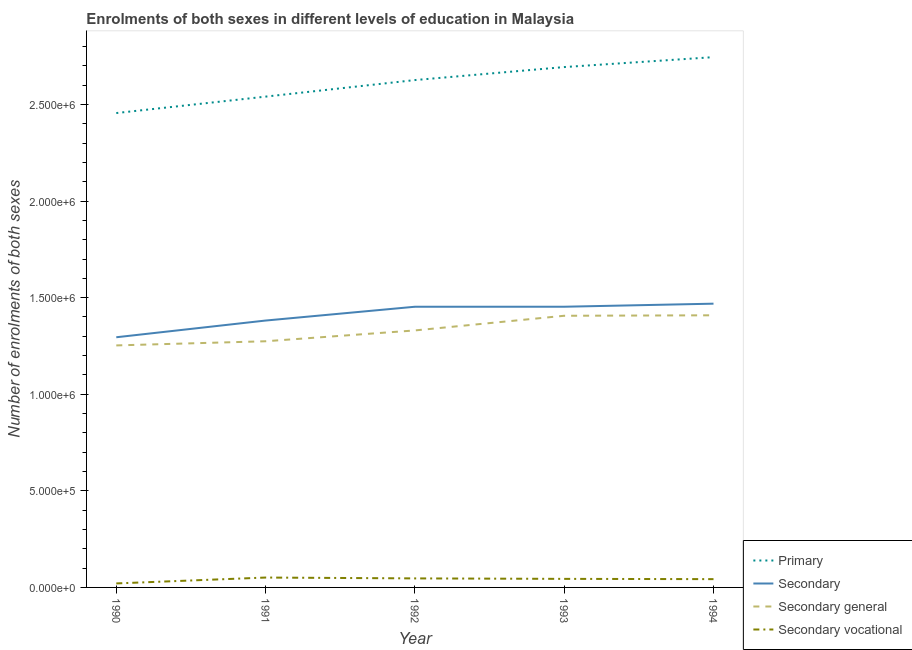How many different coloured lines are there?
Ensure brevity in your answer.  4. Does the line corresponding to number of enrolments in primary education intersect with the line corresponding to number of enrolments in secondary education?
Ensure brevity in your answer.  No. What is the number of enrolments in primary education in 1991?
Make the answer very short. 2.54e+06. Across all years, what is the maximum number of enrolments in secondary vocational education?
Provide a short and direct response. 5.12e+04. Across all years, what is the minimum number of enrolments in secondary general education?
Offer a terse response. 1.25e+06. What is the total number of enrolments in secondary education in the graph?
Your answer should be compact. 7.05e+06. What is the difference between the number of enrolments in secondary education in 1991 and that in 1992?
Make the answer very short. -7.14e+04. What is the difference between the number of enrolments in secondary general education in 1992 and the number of enrolments in secondary vocational education in 1990?
Ensure brevity in your answer.  1.31e+06. What is the average number of enrolments in secondary general education per year?
Your answer should be very brief. 1.33e+06. In the year 1994, what is the difference between the number of enrolments in secondary education and number of enrolments in secondary vocational education?
Your answer should be compact. 1.43e+06. In how many years, is the number of enrolments in secondary education greater than 200000?
Ensure brevity in your answer.  5. What is the ratio of the number of enrolments in secondary vocational education in 1991 to that in 1994?
Offer a very short reply. 1.19. Is the difference between the number of enrolments in secondary education in 1992 and 1993 greater than the difference between the number of enrolments in primary education in 1992 and 1993?
Provide a succinct answer. Yes. What is the difference between the highest and the second highest number of enrolments in secondary education?
Your answer should be compact. 1.59e+04. What is the difference between the highest and the lowest number of enrolments in primary education?
Keep it short and to the point. 2.89e+05. In how many years, is the number of enrolments in secondary vocational education greater than the average number of enrolments in secondary vocational education taken over all years?
Keep it short and to the point. 4. Is the sum of the number of enrolments in primary education in 1990 and 1992 greater than the maximum number of enrolments in secondary general education across all years?
Give a very brief answer. Yes. Is it the case that in every year, the sum of the number of enrolments in primary education and number of enrolments in secondary education is greater than the number of enrolments in secondary general education?
Make the answer very short. Yes. Is the number of enrolments in primary education strictly less than the number of enrolments in secondary education over the years?
Offer a terse response. No. How many lines are there?
Keep it short and to the point. 4. How many years are there in the graph?
Make the answer very short. 5. Are the values on the major ticks of Y-axis written in scientific E-notation?
Provide a short and direct response. Yes. Does the graph contain any zero values?
Your answer should be compact. No. Does the graph contain grids?
Your answer should be very brief. No. Where does the legend appear in the graph?
Ensure brevity in your answer.  Bottom right. How are the legend labels stacked?
Give a very brief answer. Vertical. What is the title of the graph?
Make the answer very short. Enrolments of both sexes in different levels of education in Malaysia. What is the label or title of the Y-axis?
Offer a terse response. Number of enrolments of both sexes. What is the Number of enrolments of both sexes of Primary in 1990?
Provide a short and direct response. 2.46e+06. What is the Number of enrolments of both sexes in Secondary in 1990?
Give a very brief answer. 1.29e+06. What is the Number of enrolments of both sexes in Secondary general in 1990?
Your answer should be very brief. 1.25e+06. What is the Number of enrolments of both sexes in Secondary vocational in 1990?
Your answer should be very brief. 2.07e+04. What is the Number of enrolments of both sexes of Primary in 1991?
Your response must be concise. 2.54e+06. What is the Number of enrolments of both sexes of Secondary in 1991?
Your answer should be compact. 1.38e+06. What is the Number of enrolments of both sexes in Secondary general in 1991?
Offer a terse response. 1.27e+06. What is the Number of enrolments of both sexes in Secondary vocational in 1991?
Ensure brevity in your answer.  5.12e+04. What is the Number of enrolments of both sexes in Primary in 1992?
Give a very brief answer. 2.63e+06. What is the Number of enrolments of both sexes in Secondary in 1992?
Make the answer very short. 1.45e+06. What is the Number of enrolments of both sexes in Secondary general in 1992?
Provide a short and direct response. 1.33e+06. What is the Number of enrolments of both sexes of Secondary vocational in 1992?
Offer a terse response. 4.67e+04. What is the Number of enrolments of both sexes of Primary in 1993?
Your answer should be compact. 2.69e+06. What is the Number of enrolments of both sexes in Secondary in 1993?
Offer a terse response. 1.45e+06. What is the Number of enrolments of both sexes in Secondary general in 1993?
Your response must be concise. 1.41e+06. What is the Number of enrolments of both sexes in Secondary vocational in 1993?
Provide a short and direct response. 4.43e+04. What is the Number of enrolments of both sexes of Primary in 1994?
Your answer should be compact. 2.74e+06. What is the Number of enrolments of both sexes of Secondary in 1994?
Offer a very short reply. 1.47e+06. What is the Number of enrolments of both sexes of Secondary general in 1994?
Ensure brevity in your answer.  1.41e+06. What is the Number of enrolments of both sexes in Secondary vocational in 1994?
Your response must be concise. 4.29e+04. Across all years, what is the maximum Number of enrolments of both sexes of Primary?
Provide a succinct answer. 2.74e+06. Across all years, what is the maximum Number of enrolments of both sexes in Secondary?
Keep it short and to the point. 1.47e+06. Across all years, what is the maximum Number of enrolments of both sexes of Secondary general?
Offer a terse response. 1.41e+06. Across all years, what is the maximum Number of enrolments of both sexes of Secondary vocational?
Your answer should be very brief. 5.12e+04. Across all years, what is the minimum Number of enrolments of both sexes of Primary?
Keep it short and to the point. 2.46e+06. Across all years, what is the minimum Number of enrolments of both sexes in Secondary?
Your answer should be compact. 1.29e+06. Across all years, what is the minimum Number of enrolments of both sexes of Secondary general?
Provide a succinct answer. 1.25e+06. Across all years, what is the minimum Number of enrolments of both sexes in Secondary vocational?
Offer a very short reply. 2.07e+04. What is the total Number of enrolments of both sexes in Primary in the graph?
Keep it short and to the point. 1.31e+07. What is the total Number of enrolments of both sexes of Secondary in the graph?
Ensure brevity in your answer.  7.05e+06. What is the total Number of enrolments of both sexes in Secondary general in the graph?
Provide a succinct answer. 6.67e+06. What is the total Number of enrolments of both sexes of Secondary vocational in the graph?
Make the answer very short. 2.06e+05. What is the difference between the Number of enrolments of both sexes of Primary in 1990 and that in 1991?
Keep it short and to the point. -8.51e+04. What is the difference between the Number of enrolments of both sexes of Secondary in 1990 and that in 1991?
Ensure brevity in your answer.  -8.65e+04. What is the difference between the Number of enrolments of both sexes of Secondary general in 1990 and that in 1991?
Give a very brief answer. -2.15e+04. What is the difference between the Number of enrolments of both sexes of Secondary vocational in 1990 and that in 1991?
Your answer should be compact. -3.04e+04. What is the difference between the Number of enrolments of both sexes of Primary in 1990 and that in 1992?
Make the answer very short. -1.71e+05. What is the difference between the Number of enrolments of both sexes in Secondary in 1990 and that in 1992?
Your answer should be very brief. -1.58e+05. What is the difference between the Number of enrolments of both sexes in Secondary general in 1990 and that in 1992?
Give a very brief answer. -7.76e+04. What is the difference between the Number of enrolments of both sexes of Secondary vocational in 1990 and that in 1992?
Keep it short and to the point. -2.60e+04. What is the difference between the Number of enrolments of both sexes in Primary in 1990 and that in 1993?
Keep it short and to the point. -2.38e+05. What is the difference between the Number of enrolments of both sexes of Secondary in 1990 and that in 1993?
Your answer should be compact. -1.58e+05. What is the difference between the Number of enrolments of both sexes of Secondary general in 1990 and that in 1993?
Give a very brief answer. -1.53e+05. What is the difference between the Number of enrolments of both sexes of Secondary vocational in 1990 and that in 1993?
Ensure brevity in your answer.  -2.36e+04. What is the difference between the Number of enrolments of both sexes of Primary in 1990 and that in 1994?
Give a very brief answer. -2.89e+05. What is the difference between the Number of enrolments of both sexes in Secondary in 1990 and that in 1994?
Provide a short and direct response. -1.74e+05. What is the difference between the Number of enrolments of both sexes in Secondary general in 1990 and that in 1994?
Offer a very short reply. -1.56e+05. What is the difference between the Number of enrolments of both sexes of Secondary vocational in 1990 and that in 1994?
Your answer should be very brief. -2.22e+04. What is the difference between the Number of enrolments of both sexes in Primary in 1991 and that in 1992?
Offer a terse response. -8.57e+04. What is the difference between the Number of enrolments of both sexes in Secondary in 1991 and that in 1992?
Make the answer very short. -7.14e+04. What is the difference between the Number of enrolments of both sexes of Secondary general in 1991 and that in 1992?
Provide a succinct answer. -5.61e+04. What is the difference between the Number of enrolments of both sexes of Secondary vocational in 1991 and that in 1992?
Make the answer very short. 4465. What is the difference between the Number of enrolments of both sexes of Primary in 1991 and that in 1993?
Provide a short and direct response. -1.53e+05. What is the difference between the Number of enrolments of both sexes in Secondary in 1991 and that in 1993?
Make the answer very short. -7.15e+04. What is the difference between the Number of enrolments of both sexes of Secondary general in 1991 and that in 1993?
Make the answer very short. -1.32e+05. What is the difference between the Number of enrolments of both sexes of Secondary vocational in 1991 and that in 1993?
Provide a succinct answer. 6869. What is the difference between the Number of enrolments of both sexes of Primary in 1991 and that in 1994?
Provide a short and direct response. -2.04e+05. What is the difference between the Number of enrolments of both sexes in Secondary in 1991 and that in 1994?
Make the answer very short. -8.73e+04. What is the difference between the Number of enrolments of both sexes in Secondary general in 1991 and that in 1994?
Your response must be concise. -1.34e+05. What is the difference between the Number of enrolments of both sexes in Secondary vocational in 1991 and that in 1994?
Give a very brief answer. 8262. What is the difference between the Number of enrolments of both sexes of Primary in 1992 and that in 1993?
Provide a succinct answer. -6.73e+04. What is the difference between the Number of enrolments of both sexes of Secondary in 1992 and that in 1993?
Give a very brief answer. -42. What is the difference between the Number of enrolments of both sexes in Secondary general in 1992 and that in 1993?
Provide a short and direct response. -7.59e+04. What is the difference between the Number of enrolments of both sexes in Secondary vocational in 1992 and that in 1993?
Provide a succinct answer. 2404. What is the difference between the Number of enrolments of both sexes in Primary in 1992 and that in 1994?
Offer a terse response. -1.19e+05. What is the difference between the Number of enrolments of both sexes in Secondary in 1992 and that in 1994?
Provide a succinct answer. -1.59e+04. What is the difference between the Number of enrolments of both sexes in Secondary general in 1992 and that in 1994?
Provide a short and direct response. -7.83e+04. What is the difference between the Number of enrolments of both sexes of Secondary vocational in 1992 and that in 1994?
Keep it short and to the point. 3797. What is the difference between the Number of enrolments of both sexes in Primary in 1993 and that in 1994?
Make the answer very short. -5.14e+04. What is the difference between the Number of enrolments of both sexes in Secondary in 1993 and that in 1994?
Give a very brief answer. -1.59e+04. What is the difference between the Number of enrolments of both sexes in Secondary general in 1993 and that in 1994?
Provide a succinct answer. -2446. What is the difference between the Number of enrolments of both sexes in Secondary vocational in 1993 and that in 1994?
Provide a succinct answer. 1393. What is the difference between the Number of enrolments of both sexes in Primary in 1990 and the Number of enrolments of both sexes in Secondary in 1991?
Make the answer very short. 1.07e+06. What is the difference between the Number of enrolments of both sexes of Primary in 1990 and the Number of enrolments of both sexes of Secondary general in 1991?
Keep it short and to the point. 1.18e+06. What is the difference between the Number of enrolments of both sexes in Primary in 1990 and the Number of enrolments of both sexes in Secondary vocational in 1991?
Offer a terse response. 2.40e+06. What is the difference between the Number of enrolments of both sexes of Secondary in 1990 and the Number of enrolments of both sexes of Secondary general in 1991?
Ensure brevity in your answer.  2.07e+04. What is the difference between the Number of enrolments of both sexes in Secondary in 1990 and the Number of enrolments of both sexes in Secondary vocational in 1991?
Provide a short and direct response. 1.24e+06. What is the difference between the Number of enrolments of both sexes in Secondary general in 1990 and the Number of enrolments of both sexes in Secondary vocational in 1991?
Provide a succinct answer. 1.20e+06. What is the difference between the Number of enrolments of both sexes in Primary in 1990 and the Number of enrolments of both sexes in Secondary in 1992?
Ensure brevity in your answer.  1.00e+06. What is the difference between the Number of enrolments of both sexes in Primary in 1990 and the Number of enrolments of both sexes in Secondary general in 1992?
Provide a succinct answer. 1.13e+06. What is the difference between the Number of enrolments of both sexes of Primary in 1990 and the Number of enrolments of both sexes of Secondary vocational in 1992?
Give a very brief answer. 2.41e+06. What is the difference between the Number of enrolments of both sexes in Secondary in 1990 and the Number of enrolments of both sexes in Secondary general in 1992?
Keep it short and to the point. -3.53e+04. What is the difference between the Number of enrolments of both sexes in Secondary in 1990 and the Number of enrolments of both sexes in Secondary vocational in 1992?
Make the answer very short. 1.25e+06. What is the difference between the Number of enrolments of both sexes of Secondary general in 1990 and the Number of enrolments of both sexes of Secondary vocational in 1992?
Your answer should be very brief. 1.21e+06. What is the difference between the Number of enrolments of both sexes of Primary in 1990 and the Number of enrolments of both sexes of Secondary in 1993?
Your response must be concise. 1.00e+06. What is the difference between the Number of enrolments of both sexes in Primary in 1990 and the Number of enrolments of both sexes in Secondary general in 1993?
Keep it short and to the point. 1.05e+06. What is the difference between the Number of enrolments of both sexes of Primary in 1990 and the Number of enrolments of both sexes of Secondary vocational in 1993?
Ensure brevity in your answer.  2.41e+06. What is the difference between the Number of enrolments of both sexes of Secondary in 1990 and the Number of enrolments of both sexes of Secondary general in 1993?
Your answer should be very brief. -1.11e+05. What is the difference between the Number of enrolments of both sexes in Secondary in 1990 and the Number of enrolments of both sexes in Secondary vocational in 1993?
Your answer should be compact. 1.25e+06. What is the difference between the Number of enrolments of both sexes of Secondary general in 1990 and the Number of enrolments of both sexes of Secondary vocational in 1993?
Offer a very short reply. 1.21e+06. What is the difference between the Number of enrolments of both sexes of Primary in 1990 and the Number of enrolments of both sexes of Secondary in 1994?
Offer a very short reply. 9.87e+05. What is the difference between the Number of enrolments of both sexes of Primary in 1990 and the Number of enrolments of both sexes of Secondary general in 1994?
Your response must be concise. 1.05e+06. What is the difference between the Number of enrolments of both sexes in Primary in 1990 and the Number of enrolments of both sexes in Secondary vocational in 1994?
Keep it short and to the point. 2.41e+06. What is the difference between the Number of enrolments of both sexes of Secondary in 1990 and the Number of enrolments of both sexes of Secondary general in 1994?
Offer a terse response. -1.14e+05. What is the difference between the Number of enrolments of both sexes of Secondary in 1990 and the Number of enrolments of both sexes of Secondary vocational in 1994?
Your answer should be compact. 1.25e+06. What is the difference between the Number of enrolments of both sexes of Secondary general in 1990 and the Number of enrolments of both sexes of Secondary vocational in 1994?
Your answer should be very brief. 1.21e+06. What is the difference between the Number of enrolments of both sexes in Primary in 1991 and the Number of enrolments of both sexes in Secondary in 1992?
Offer a very short reply. 1.09e+06. What is the difference between the Number of enrolments of both sexes in Primary in 1991 and the Number of enrolments of both sexes in Secondary general in 1992?
Offer a very short reply. 1.21e+06. What is the difference between the Number of enrolments of both sexes in Primary in 1991 and the Number of enrolments of both sexes in Secondary vocational in 1992?
Keep it short and to the point. 2.49e+06. What is the difference between the Number of enrolments of both sexes in Secondary in 1991 and the Number of enrolments of both sexes in Secondary general in 1992?
Give a very brief answer. 5.12e+04. What is the difference between the Number of enrolments of both sexes of Secondary in 1991 and the Number of enrolments of both sexes of Secondary vocational in 1992?
Offer a terse response. 1.33e+06. What is the difference between the Number of enrolments of both sexes of Secondary general in 1991 and the Number of enrolments of both sexes of Secondary vocational in 1992?
Make the answer very short. 1.23e+06. What is the difference between the Number of enrolments of both sexes of Primary in 1991 and the Number of enrolments of both sexes of Secondary in 1993?
Keep it short and to the point. 1.09e+06. What is the difference between the Number of enrolments of both sexes in Primary in 1991 and the Number of enrolments of both sexes in Secondary general in 1993?
Provide a succinct answer. 1.13e+06. What is the difference between the Number of enrolments of both sexes of Primary in 1991 and the Number of enrolments of both sexes of Secondary vocational in 1993?
Offer a very short reply. 2.50e+06. What is the difference between the Number of enrolments of both sexes of Secondary in 1991 and the Number of enrolments of both sexes of Secondary general in 1993?
Your answer should be compact. -2.47e+04. What is the difference between the Number of enrolments of both sexes in Secondary in 1991 and the Number of enrolments of both sexes in Secondary vocational in 1993?
Ensure brevity in your answer.  1.34e+06. What is the difference between the Number of enrolments of both sexes in Secondary general in 1991 and the Number of enrolments of both sexes in Secondary vocational in 1993?
Offer a very short reply. 1.23e+06. What is the difference between the Number of enrolments of both sexes in Primary in 1991 and the Number of enrolments of both sexes in Secondary in 1994?
Offer a very short reply. 1.07e+06. What is the difference between the Number of enrolments of both sexes of Primary in 1991 and the Number of enrolments of both sexes of Secondary general in 1994?
Ensure brevity in your answer.  1.13e+06. What is the difference between the Number of enrolments of both sexes in Primary in 1991 and the Number of enrolments of both sexes in Secondary vocational in 1994?
Make the answer very short. 2.50e+06. What is the difference between the Number of enrolments of both sexes in Secondary in 1991 and the Number of enrolments of both sexes in Secondary general in 1994?
Your answer should be very brief. -2.72e+04. What is the difference between the Number of enrolments of both sexes of Secondary in 1991 and the Number of enrolments of both sexes of Secondary vocational in 1994?
Your answer should be very brief. 1.34e+06. What is the difference between the Number of enrolments of both sexes of Secondary general in 1991 and the Number of enrolments of both sexes of Secondary vocational in 1994?
Provide a succinct answer. 1.23e+06. What is the difference between the Number of enrolments of both sexes in Primary in 1992 and the Number of enrolments of both sexes in Secondary in 1993?
Offer a terse response. 1.17e+06. What is the difference between the Number of enrolments of both sexes of Primary in 1992 and the Number of enrolments of both sexes of Secondary general in 1993?
Keep it short and to the point. 1.22e+06. What is the difference between the Number of enrolments of both sexes in Primary in 1992 and the Number of enrolments of both sexes in Secondary vocational in 1993?
Ensure brevity in your answer.  2.58e+06. What is the difference between the Number of enrolments of both sexes in Secondary in 1992 and the Number of enrolments of both sexes in Secondary general in 1993?
Offer a terse response. 4.67e+04. What is the difference between the Number of enrolments of both sexes in Secondary in 1992 and the Number of enrolments of both sexes in Secondary vocational in 1993?
Give a very brief answer. 1.41e+06. What is the difference between the Number of enrolments of both sexes of Secondary general in 1992 and the Number of enrolments of both sexes of Secondary vocational in 1993?
Your answer should be compact. 1.29e+06. What is the difference between the Number of enrolments of both sexes of Primary in 1992 and the Number of enrolments of both sexes of Secondary in 1994?
Offer a very short reply. 1.16e+06. What is the difference between the Number of enrolments of both sexes in Primary in 1992 and the Number of enrolments of both sexes in Secondary general in 1994?
Ensure brevity in your answer.  1.22e+06. What is the difference between the Number of enrolments of both sexes in Primary in 1992 and the Number of enrolments of both sexes in Secondary vocational in 1994?
Make the answer very short. 2.58e+06. What is the difference between the Number of enrolments of both sexes in Secondary in 1992 and the Number of enrolments of both sexes in Secondary general in 1994?
Give a very brief answer. 4.43e+04. What is the difference between the Number of enrolments of both sexes in Secondary in 1992 and the Number of enrolments of both sexes in Secondary vocational in 1994?
Provide a short and direct response. 1.41e+06. What is the difference between the Number of enrolments of both sexes in Secondary general in 1992 and the Number of enrolments of both sexes in Secondary vocational in 1994?
Make the answer very short. 1.29e+06. What is the difference between the Number of enrolments of both sexes in Primary in 1993 and the Number of enrolments of both sexes in Secondary in 1994?
Offer a very short reply. 1.22e+06. What is the difference between the Number of enrolments of both sexes in Primary in 1993 and the Number of enrolments of both sexes in Secondary general in 1994?
Your answer should be very brief. 1.28e+06. What is the difference between the Number of enrolments of both sexes of Primary in 1993 and the Number of enrolments of both sexes of Secondary vocational in 1994?
Your answer should be very brief. 2.65e+06. What is the difference between the Number of enrolments of both sexes in Secondary in 1993 and the Number of enrolments of both sexes in Secondary general in 1994?
Ensure brevity in your answer.  4.43e+04. What is the difference between the Number of enrolments of both sexes of Secondary in 1993 and the Number of enrolments of both sexes of Secondary vocational in 1994?
Ensure brevity in your answer.  1.41e+06. What is the difference between the Number of enrolments of both sexes of Secondary general in 1993 and the Number of enrolments of both sexes of Secondary vocational in 1994?
Keep it short and to the point. 1.36e+06. What is the average Number of enrolments of both sexes in Primary per year?
Ensure brevity in your answer.  2.61e+06. What is the average Number of enrolments of both sexes of Secondary per year?
Give a very brief answer. 1.41e+06. What is the average Number of enrolments of both sexes in Secondary general per year?
Ensure brevity in your answer.  1.33e+06. What is the average Number of enrolments of both sexes of Secondary vocational per year?
Your response must be concise. 4.12e+04. In the year 1990, what is the difference between the Number of enrolments of both sexes of Primary and Number of enrolments of both sexes of Secondary?
Offer a terse response. 1.16e+06. In the year 1990, what is the difference between the Number of enrolments of both sexes of Primary and Number of enrolments of both sexes of Secondary general?
Your answer should be very brief. 1.20e+06. In the year 1990, what is the difference between the Number of enrolments of both sexes in Primary and Number of enrolments of both sexes in Secondary vocational?
Your answer should be very brief. 2.43e+06. In the year 1990, what is the difference between the Number of enrolments of both sexes of Secondary and Number of enrolments of both sexes of Secondary general?
Your response must be concise. 4.22e+04. In the year 1990, what is the difference between the Number of enrolments of both sexes in Secondary and Number of enrolments of both sexes in Secondary vocational?
Offer a terse response. 1.27e+06. In the year 1990, what is the difference between the Number of enrolments of both sexes of Secondary general and Number of enrolments of both sexes of Secondary vocational?
Ensure brevity in your answer.  1.23e+06. In the year 1991, what is the difference between the Number of enrolments of both sexes of Primary and Number of enrolments of both sexes of Secondary?
Ensure brevity in your answer.  1.16e+06. In the year 1991, what is the difference between the Number of enrolments of both sexes of Primary and Number of enrolments of both sexes of Secondary general?
Provide a succinct answer. 1.27e+06. In the year 1991, what is the difference between the Number of enrolments of both sexes in Primary and Number of enrolments of both sexes in Secondary vocational?
Give a very brief answer. 2.49e+06. In the year 1991, what is the difference between the Number of enrolments of both sexes of Secondary and Number of enrolments of both sexes of Secondary general?
Offer a terse response. 1.07e+05. In the year 1991, what is the difference between the Number of enrolments of both sexes of Secondary and Number of enrolments of both sexes of Secondary vocational?
Provide a short and direct response. 1.33e+06. In the year 1991, what is the difference between the Number of enrolments of both sexes of Secondary general and Number of enrolments of both sexes of Secondary vocational?
Ensure brevity in your answer.  1.22e+06. In the year 1992, what is the difference between the Number of enrolments of both sexes in Primary and Number of enrolments of both sexes in Secondary?
Provide a succinct answer. 1.17e+06. In the year 1992, what is the difference between the Number of enrolments of both sexes in Primary and Number of enrolments of both sexes in Secondary general?
Your answer should be compact. 1.30e+06. In the year 1992, what is the difference between the Number of enrolments of both sexes in Primary and Number of enrolments of both sexes in Secondary vocational?
Offer a very short reply. 2.58e+06. In the year 1992, what is the difference between the Number of enrolments of both sexes in Secondary and Number of enrolments of both sexes in Secondary general?
Keep it short and to the point. 1.23e+05. In the year 1992, what is the difference between the Number of enrolments of both sexes of Secondary and Number of enrolments of both sexes of Secondary vocational?
Provide a succinct answer. 1.41e+06. In the year 1992, what is the difference between the Number of enrolments of both sexes in Secondary general and Number of enrolments of both sexes in Secondary vocational?
Your response must be concise. 1.28e+06. In the year 1993, what is the difference between the Number of enrolments of both sexes in Primary and Number of enrolments of both sexes in Secondary?
Offer a terse response. 1.24e+06. In the year 1993, what is the difference between the Number of enrolments of both sexes of Primary and Number of enrolments of both sexes of Secondary general?
Your answer should be compact. 1.29e+06. In the year 1993, what is the difference between the Number of enrolments of both sexes of Primary and Number of enrolments of both sexes of Secondary vocational?
Keep it short and to the point. 2.65e+06. In the year 1993, what is the difference between the Number of enrolments of both sexes in Secondary and Number of enrolments of both sexes in Secondary general?
Your answer should be very brief. 4.67e+04. In the year 1993, what is the difference between the Number of enrolments of both sexes of Secondary and Number of enrolments of both sexes of Secondary vocational?
Provide a succinct answer. 1.41e+06. In the year 1993, what is the difference between the Number of enrolments of both sexes in Secondary general and Number of enrolments of both sexes in Secondary vocational?
Offer a terse response. 1.36e+06. In the year 1994, what is the difference between the Number of enrolments of both sexes in Primary and Number of enrolments of both sexes in Secondary?
Ensure brevity in your answer.  1.28e+06. In the year 1994, what is the difference between the Number of enrolments of both sexes of Primary and Number of enrolments of both sexes of Secondary general?
Provide a short and direct response. 1.34e+06. In the year 1994, what is the difference between the Number of enrolments of both sexes of Primary and Number of enrolments of both sexes of Secondary vocational?
Provide a succinct answer. 2.70e+06. In the year 1994, what is the difference between the Number of enrolments of both sexes of Secondary and Number of enrolments of both sexes of Secondary general?
Make the answer very short. 6.02e+04. In the year 1994, what is the difference between the Number of enrolments of both sexes in Secondary and Number of enrolments of both sexes in Secondary vocational?
Make the answer very short. 1.43e+06. In the year 1994, what is the difference between the Number of enrolments of both sexes in Secondary general and Number of enrolments of both sexes in Secondary vocational?
Provide a short and direct response. 1.37e+06. What is the ratio of the Number of enrolments of both sexes of Primary in 1990 to that in 1991?
Your answer should be very brief. 0.97. What is the ratio of the Number of enrolments of both sexes of Secondary in 1990 to that in 1991?
Your response must be concise. 0.94. What is the ratio of the Number of enrolments of both sexes of Secondary general in 1990 to that in 1991?
Your response must be concise. 0.98. What is the ratio of the Number of enrolments of both sexes in Secondary vocational in 1990 to that in 1991?
Ensure brevity in your answer.  0.4. What is the ratio of the Number of enrolments of both sexes of Primary in 1990 to that in 1992?
Your answer should be compact. 0.94. What is the ratio of the Number of enrolments of both sexes of Secondary in 1990 to that in 1992?
Your answer should be compact. 0.89. What is the ratio of the Number of enrolments of both sexes in Secondary general in 1990 to that in 1992?
Your answer should be compact. 0.94. What is the ratio of the Number of enrolments of both sexes of Secondary vocational in 1990 to that in 1992?
Your answer should be very brief. 0.44. What is the ratio of the Number of enrolments of both sexes in Primary in 1990 to that in 1993?
Give a very brief answer. 0.91. What is the ratio of the Number of enrolments of both sexes of Secondary in 1990 to that in 1993?
Offer a very short reply. 0.89. What is the ratio of the Number of enrolments of both sexes in Secondary general in 1990 to that in 1993?
Provide a short and direct response. 0.89. What is the ratio of the Number of enrolments of both sexes of Secondary vocational in 1990 to that in 1993?
Offer a very short reply. 0.47. What is the ratio of the Number of enrolments of both sexes in Primary in 1990 to that in 1994?
Make the answer very short. 0.89. What is the ratio of the Number of enrolments of both sexes of Secondary in 1990 to that in 1994?
Ensure brevity in your answer.  0.88. What is the ratio of the Number of enrolments of both sexes in Secondary general in 1990 to that in 1994?
Your response must be concise. 0.89. What is the ratio of the Number of enrolments of both sexes of Secondary vocational in 1990 to that in 1994?
Offer a terse response. 0.48. What is the ratio of the Number of enrolments of both sexes in Primary in 1991 to that in 1992?
Give a very brief answer. 0.97. What is the ratio of the Number of enrolments of both sexes in Secondary in 1991 to that in 1992?
Provide a short and direct response. 0.95. What is the ratio of the Number of enrolments of both sexes in Secondary general in 1991 to that in 1992?
Give a very brief answer. 0.96. What is the ratio of the Number of enrolments of both sexes of Secondary vocational in 1991 to that in 1992?
Your answer should be compact. 1.1. What is the ratio of the Number of enrolments of both sexes in Primary in 1991 to that in 1993?
Give a very brief answer. 0.94. What is the ratio of the Number of enrolments of both sexes in Secondary in 1991 to that in 1993?
Provide a succinct answer. 0.95. What is the ratio of the Number of enrolments of both sexes of Secondary general in 1991 to that in 1993?
Your answer should be compact. 0.91. What is the ratio of the Number of enrolments of both sexes in Secondary vocational in 1991 to that in 1993?
Make the answer very short. 1.16. What is the ratio of the Number of enrolments of both sexes of Primary in 1991 to that in 1994?
Keep it short and to the point. 0.93. What is the ratio of the Number of enrolments of both sexes of Secondary in 1991 to that in 1994?
Offer a terse response. 0.94. What is the ratio of the Number of enrolments of both sexes of Secondary general in 1991 to that in 1994?
Your response must be concise. 0.9. What is the ratio of the Number of enrolments of both sexes in Secondary vocational in 1991 to that in 1994?
Ensure brevity in your answer.  1.19. What is the ratio of the Number of enrolments of both sexes in Primary in 1992 to that in 1993?
Keep it short and to the point. 0.97. What is the ratio of the Number of enrolments of both sexes in Secondary in 1992 to that in 1993?
Your answer should be very brief. 1. What is the ratio of the Number of enrolments of both sexes of Secondary general in 1992 to that in 1993?
Offer a terse response. 0.95. What is the ratio of the Number of enrolments of both sexes of Secondary vocational in 1992 to that in 1993?
Make the answer very short. 1.05. What is the ratio of the Number of enrolments of both sexes of Primary in 1992 to that in 1994?
Your response must be concise. 0.96. What is the ratio of the Number of enrolments of both sexes in Secondary in 1992 to that in 1994?
Offer a terse response. 0.99. What is the ratio of the Number of enrolments of both sexes in Secondary vocational in 1992 to that in 1994?
Ensure brevity in your answer.  1.09. What is the ratio of the Number of enrolments of both sexes in Primary in 1993 to that in 1994?
Keep it short and to the point. 0.98. What is the ratio of the Number of enrolments of both sexes in Secondary in 1993 to that in 1994?
Offer a terse response. 0.99. What is the ratio of the Number of enrolments of both sexes of Secondary general in 1993 to that in 1994?
Give a very brief answer. 1. What is the ratio of the Number of enrolments of both sexes of Secondary vocational in 1993 to that in 1994?
Provide a succinct answer. 1.03. What is the difference between the highest and the second highest Number of enrolments of both sexes of Primary?
Provide a succinct answer. 5.14e+04. What is the difference between the highest and the second highest Number of enrolments of both sexes of Secondary?
Give a very brief answer. 1.59e+04. What is the difference between the highest and the second highest Number of enrolments of both sexes in Secondary general?
Offer a very short reply. 2446. What is the difference between the highest and the second highest Number of enrolments of both sexes of Secondary vocational?
Provide a succinct answer. 4465. What is the difference between the highest and the lowest Number of enrolments of both sexes in Primary?
Your answer should be compact. 2.89e+05. What is the difference between the highest and the lowest Number of enrolments of both sexes of Secondary?
Give a very brief answer. 1.74e+05. What is the difference between the highest and the lowest Number of enrolments of both sexes of Secondary general?
Keep it short and to the point. 1.56e+05. What is the difference between the highest and the lowest Number of enrolments of both sexes in Secondary vocational?
Your answer should be very brief. 3.04e+04. 